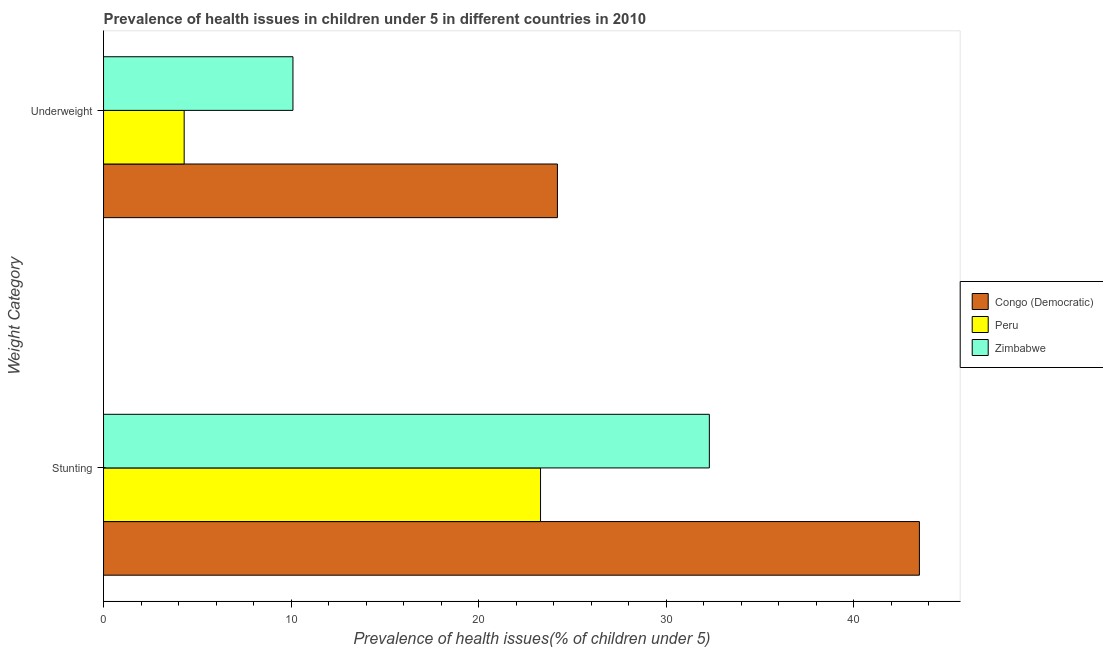How many different coloured bars are there?
Offer a very short reply. 3. How many groups of bars are there?
Make the answer very short. 2. Are the number of bars on each tick of the Y-axis equal?
Ensure brevity in your answer.  Yes. How many bars are there on the 1st tick from the top?
Ensure brevity in your answer.  3. What is the label of the 2nd group of bars from the top?
Ensure brevity in your answer.  Stunting. What is the percentage of stunted children in Congo (Democratic)?
Ensure brevity in your answer.  43.5. Across all countries, what is the maximum percentage of underweight children?
Keep it short and to the point. 24.2. Across all countries, what is the minimum percentage of underweight children?
Your answer should be compact. 4.3. In which country was the percentage of underweight children maximum?
Give a very brief answer. Congo (Democratic). In which country was the percentage of underweight children minimum?
Ensure brevity in your answer.  Peru. What is the total percentage of stunted children in the graph?
Keep it short and to the point. 99.1. What is the difference between the percentage of underweight children in Peru and that in Congo (Democratic)?
Provide a short and direct response. -19.9. What is the difference between the percentage of stunted children in Peru and the percentage of underweight children in Congo (Democratic)?
Offer a very short reply. -0.9. What is the average percentage of underweight children per country?
Your answer should be compact. 12.87. What is the difference between the percentage of underweight children and percentage of stunted children in Congo (Democratic)?
Provide a short and direct response. -19.3. In how many countries, is the percentage of underweight children greater than 30 %?
Your response must be concise. 0. What is the ratio of the percentage of stunted children in Zimbabwe to that in Peru?
Your answer should be compact. 1.39. Is the percentage of stunted children in Congo (Democratic) less than that in Peru?
Ensure brevity in your answer.  No. What does the 2nd bar from the bottom in Underweight represents?
Offer a terse response. Peru. How many bars are there?
Make the answer very short. 6. How many countries are there in the graph?
Make the answer very short. 3. What is the difference between two consecutive major ticks on the X-axis?
Keep it short and to the point. 10. Are the values on the major ticks of X-axis written in scientific E-notation?
Provide a succinct answer. No. Does the graph contain grids?
Give a very brief answer. No. How are the legend labels stacked?
Your answer should be compact. Vertical. What is the title of the graph?
Offer a very short reply. Prevalence of health issues in children under 5 in different countries in 2010. Does "Eritrea" appear as one of the legend labels in the graph?
Keep it short and to the point. No. What is the label or title of the X-axis?
Give a very brief answer. Prevalence of health issues(% of children under 5). What is the label or title of the Y-axis?
Provide a succinct answer. Weight Category. What is the Prevalence of health issues(% of children under 5) of Congo (Democratic) in Stunting?
Keep it short and to the point. 43.5. What is the Prevalence of health issues(% of children under 5) in Peru in Stunting?
Your answer should be very brief. 23.3. What is the Prevalence of health issues(% of children under 5) in Zimbabwe in Stunting?
Offer a terse response. 32.3. What is the Prevalence of health issues(% of children under 5) of Congo (Democratic) in Underweight?
Give a very brief answer. 24.2. What is the Prevalence of health issues(% of children under 5) in Peru in Underweight?
Make the answer very short. 4.3. What is the Prevalence of health issues(% of children under 5) of Zimbabwe in Underweight?
Your answer should be compact. 10.1. Across all Weight Category, what is the maximum Prevalence of health issues(% of children under 5) in Congo (Democratic)?
Make the answer very short. 43.5. Across all Weight Category, what is the maximum Prevalence of health issues(% of children under 5) in Peru?
Give a very brief answer. 23.3. Across all Weight Category, what is the maximum Prevalence of health issues(% of children under 5) of Zimbabwe?
Offer a terse response. 32.3. Across all Weight Category, what is the minimum Prevalence of health issues(% of children under 5) in Congo (Democratic)?
Give a very brief answer. 24.2. Across all Weight Category, what is the minimum Prevalence of health issues(% of children under 5) in Peru?
Offer a very short reply. 4.3. Across all Weight Category, what is the minimum Prevalence of health issues(% of children under 5) of Zimbabwe?
Make the answer very short. 10.1. What is the total Prevalence of health issues(% of children under 5) of Congo (Democratic) in the graph?
Your response must be concise. 67.7. What is the total Prevalence of health issues(% of children under 5) in Peru in the graph?
Provide a succinct answer. 27.6. What is the total Prevalence of health issues(% of children under 5) of Zimbabwe in the graph?
Provide a succinct answer. 42.4. What is the difference between the Prevalence of health issues(% of children under 5) in Congo (Democratic) in Stunting and that in Underweight?
Ensure brevity in your answer.  19.3. What is the difference between the Prevalence of health issues(% of children under 5) in Peru in Stunting and that in Underweight?
Offer a very short reply. 19. What is the difference between the Prevalence of health issues(% of children under 5) in Zimbabwe in Stunting and that in Underweight?
Provide a short and direct response. 22.2. What is the difference between the Prevalence of health issues(% of children under 5) of Congo (Democratic) in Stunting and the Prevalence of health issues(% of children under 5) of Peru in Underweight?
Provide a short and direct response. 39.2. What is the difference between the Prevalence of health issues(% of children under 5) in Congo (Democratic) in Stunting and the Prevalence of health issues(% of children under 5) in Zimbabwe in Underweight?
Offer a terse response. 33.4. What is the difference between the Prevalence of health issues(% of children under 5) in Peru in Stunting and the Prevalence of health issues(% of children under 5) in Zimbabwe in Underweight?
Offer a terse response. 13.2. What is the average Prevalence of health issues(% of children under 5) in Congo (Democratic) per Weight Category?
Your answer should be compact. 33.85. What is the average Prevalence of health issues(% of children under 5) in Peru per Weight Category?
Make the answer very short. 13.8. What is the average Prevalence of health issues(% of children under 5) in Zimbabwe per Weight Category?
Offer a terse response. 21.2. What is the difference between the Prevalence of health issues(% of children under 5) of Congo (Democratic) and Prevalence of health issues(% of children under 5) of Peru in Stunting?
Give a very brief answer. 20.2. What is the difference between the Prevalence of health issues(% of children under 5) of Congo (Democratic) and Prevalence of health issues(% of children under 5) of Peru in Underweight?
Keep it short and to the point. 19.9. What is the ratio of the Prevalence of health issues(% of children under 5) of Congo (Democratic) in Stunting to that in Underweight?
Provide a short and direct response. 1.8. What is the ratio of the Prevalence of health issues(% of children under 5) in Peru in Stunting to that in Underweight?
Your answer should be very brief. 5.42. What is the ratio of the Prevalence of health issues(% of children under 5) of Zimbabwe in Stunting to that in Underweight?
Your response must be concise. 3.2. What is the difference between the highest and the second highest Prevalence of health issues(% of children under 5) in Congo (Democratic)?
Offer a terse response. 19.3. What is the difference between the highest and the lowest Prevalence of health issues(% of children under 5) in Congo (Democratic)?
Give a very brief answer. 19.3. What is the difference between the highest and the lowest Prevalence of health issues(% of children under 5) of Peru?
Give a very brief answer. 19. 